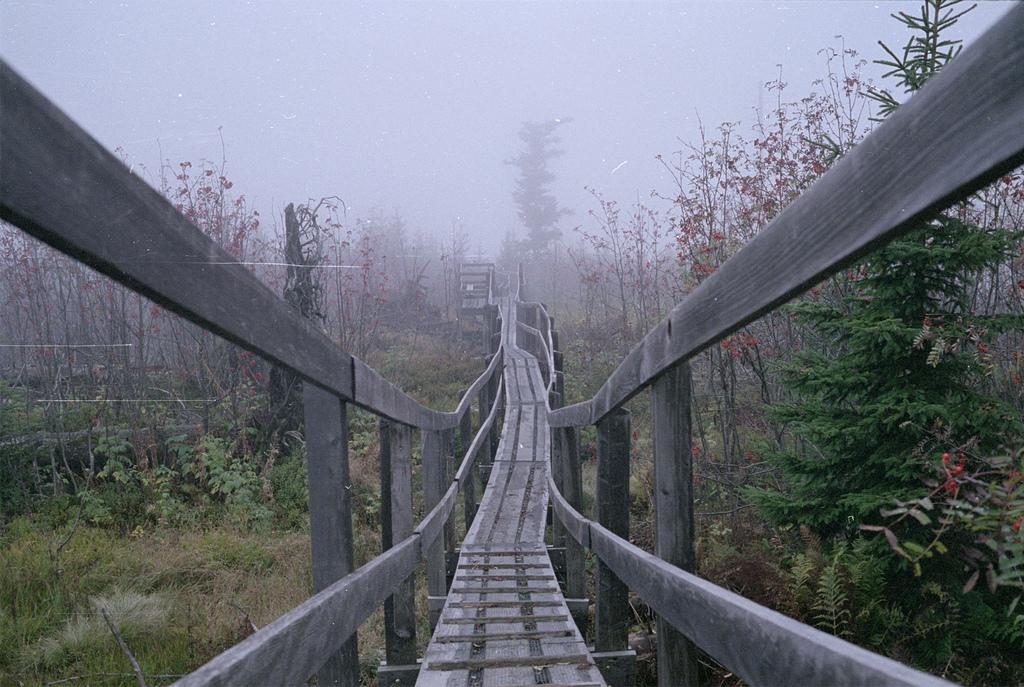What is the main structure in the image? There is a bridge in the image. What can be seen on either side of the bridge? There are trees and plants on either side of the bridge. What is visible in the background of the image? The sky is visible in the background of the image. What type of coach can be seen driving across the bridge in the image? There is no coach present in the image; it only features the bridge and the surrounding trees and plants. 